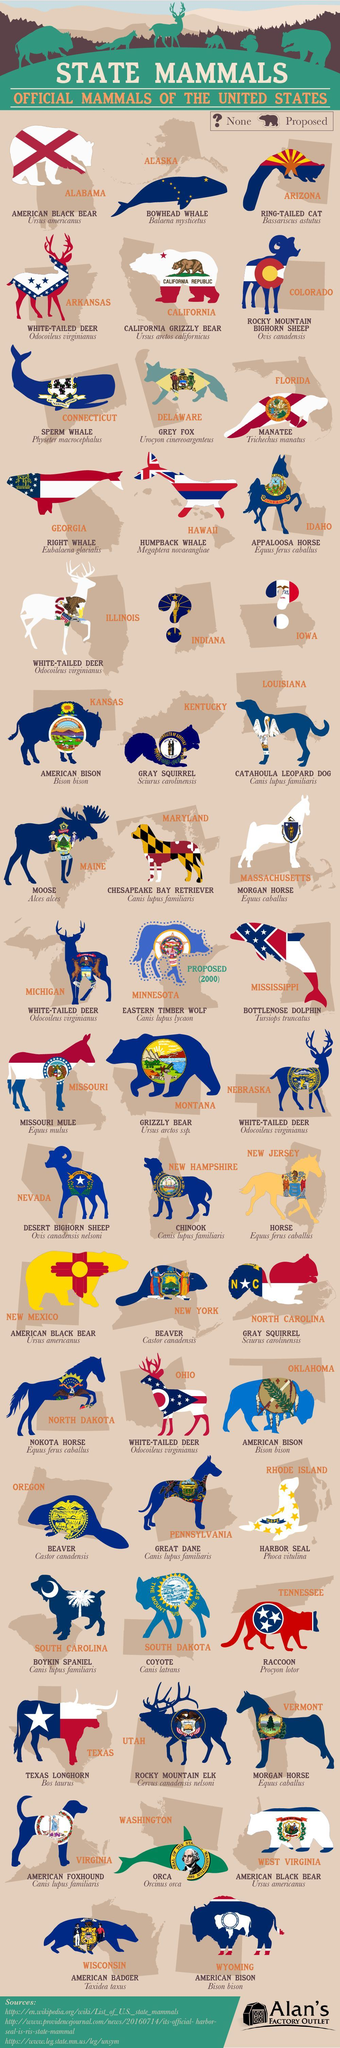What is the scientific name of the mammal Bowhead Whale?
Answer the question with a short phrase. Balaena mysticetus What is the official mammal of New Jersey? Horse Which states official mammal is Harbor Seal? Rhode Island What is the scientific name of the mammal Orca? Orcinus Orca What is the official mammal of Vermont? Morgan Horse In which state Ring Tailed Cat is found? Arizona What is the official mammal of state Maine? Moose What is the official mammal of Florida? Manatee What is the official mammal of Wisconsin? American Badger What is the scientific name of American Black Bear? Ursus americanus 